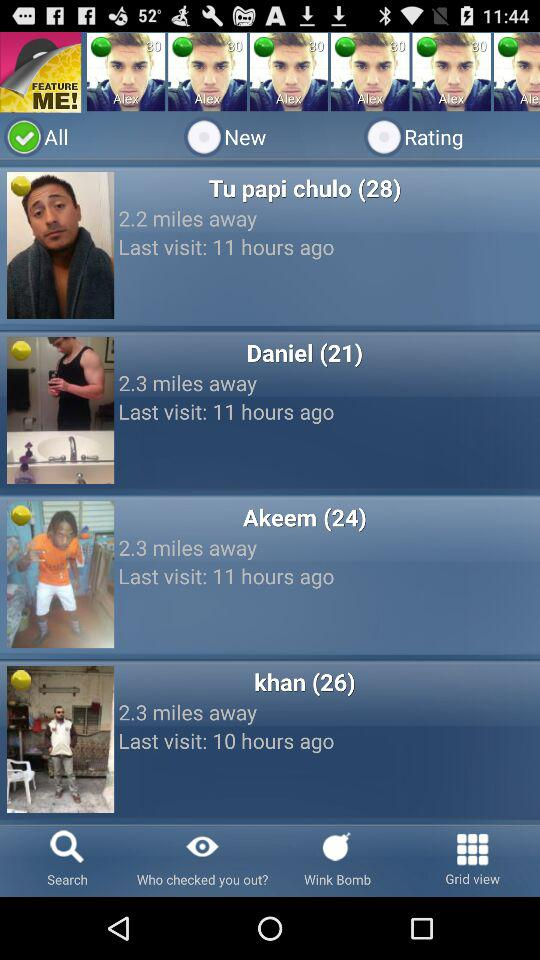What is the stated distance for Akeem? The distance is 2.3 miles. 